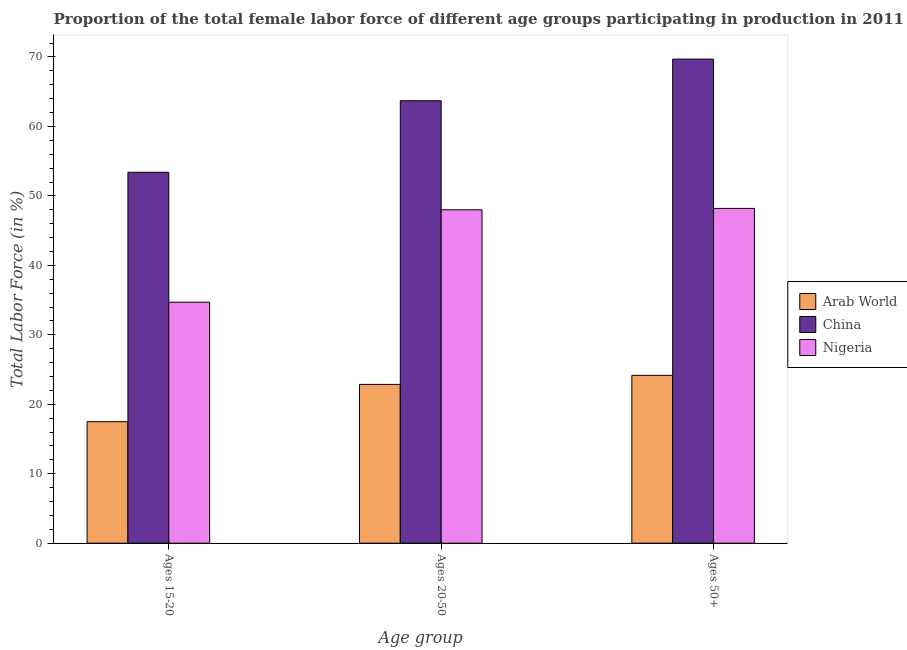How many groups of bars are there?
Offer a terse response. 3. What is the label of the 2nd group of bars from the left?
Keep it short and to the point. Ages 20-50. What is the percentage of female labor force above age 50 in Arab World?
Offer a terse response. 24.17. Across all countries, what is the maximum percentage of female labor force within the age group 15-20?
Ensure brevity in your answer.  53.4. Across all countries, what is the minimum percentage of female labor force within the age group 15-20?
Keep it short and to the point. 17.5. In which country was the percentage of female labor force within the age group 15-20 minimum?
Ensure brevity in your answer.  Arab World. What is the total percentage of female labor force within the age group 15-20 in the graph?
Offer a very short reply. 105.6. What is the difference between the percentage of female labor force within the age group 20-50 in Arab World and that in Nigeria?
Ensure brevity in your answer.  -25.14. What is the difference between the percentage of female labor force within the age group 15-20 in China and the percentage of female labor force above age 50 in Arab World?
Your answer should be very brief. 29.23. What is the average percentage of female labor force within the age group 15-20 per country?
Your response must be concise. 35.2. What is the difference between the percentage of female labor force within the age group 15-20 and percentage of female labor force above age 50 in Arab World?
Your answer should be compact. -6.67. What is the ratio of the percentage of female labor force above age 50 in Nigeria to that in Arab World?
Provide a short and direct response. 1.99. Is the percentage of female labor force above age 50 in Nigeria less than that in Arab World?
Provide a succinct answer. No. What is the difference between the highest and the second highest percentage of female labor force within the age group 20-50?
Offer a terse response. 15.7. What is the difference between the highest and the lowest percentage of female labor force above age 50?
Your answer should be very brief. 45.53. Is the sum of the percentage of female labor force above age 50 in Arab World and China greater than the maximum percentage of female labor force within the age group 15-20 across all countries?
Ensure brevity in your answer.  Yes. What does the 3rd bar from the left in Ages 20-50 represents?
Keep it short and to the point. Nigeria. What does the 1st bar from the right in Ages 20-50 represents?
Your answer should be very brief. Nigeria. Is it the case that in every country, the sum of the percentage of female labor force within the age group 15-20 and percentage of female labor force within the age group 20-50 is greater than the percentage of female labor force above age 50?
Your answer should be very brief. Yes. How many bars are there?
Your answer should be very brief. 9. Are all the bars in the graph horizontal?
Provide a succinct answer. No. How many countries are there in the graph?
Ensure brevity in your answer.  3. What is the difference between two consecutive major ticks on the Y-axis?
Your response must be concise. 10. Does the graph contain any zero values?
Keep it short and to the point. No. Where does the legend appear in the graph?
Make the answer very short. Center right. How are the legend labels stacked?
Give a very brief answer. Vertical. What is the title of the graph?
Give a very brief answer. Proportion of the total female labor force of different age groups participating in production in 2011. What is the label or title of the X-axis?
Your answer should be compact. Age group. What is the label or title of the Y-axis?
Provide a succinct answer. Total Labor Force (in %). What is the Total Labor Force (in %) of Arab World in Ages 15-20?
Give a very brief answer. 17.5. What is the Total Labor Force (in %) of China in Ages 15-20?
Offer a very short reply. 53.4. What is the Total Labor Force (in %) in Nigeria in Ages 15-20?
Offer a terse response. 34.7. What is the Total Labor Force (in %) of Arab World in Ages 20-50?
Give a very brief answer. 22.86. What is the Total Labor Force (in %) in China in Ages 20-50?
Provide a short and direct response. 63.7. What is the Total Labor Force (in %) in Nigeria in Ages 20-50?
Offer a very short reply. 48. What is the Total Labor Force (in %) in Arab World in Ages 50+?
Provide a succinct answer. 24.17. What is the Total Labor Force (in %) in China in Ages 50+?
Your response must be concise. 69.7. What is the Total Labor Force (in %) of Nigeria in Ages 50+?
Provide a succinct answer. 48.2. Across all Age group, what is the maximum Total Labor Force (in %) of Arab World?
Offer a terse response. 24.17. Across all Age group, what is the maximum Total Labor Force (in %) in China?
Offer a terse response. 69.7. Across all Age group, what is the maximum Total Labor Force (in %) in Nigeria?
Provide a short and direct response. 48.2. Across all Age group, what is the minimum Total Labor Force (in %) in Arab World?
Provide a succinct answer. 17.5. Across all Age group, what is the minimum Total Labor Force (in %) of China?
Your answer should be compact. 53.4. Across all Age group, what is the minimum Total Labor Force (in %) of Nigeria?
Your answer should be very brief. 34.7. What is the total Total Labor Force (in %) of Arab World in the graph?
Offer a terse response. 64.53. What is the total Total Labor Force (in %) in China in the graph?
Ensure brevity in your answer.  186.8. What is the total Total Labor Force (in %) of Nigeria in the graph?
Offer a very short reply. 130.9. What is the difference between the Total Labor Force (in %) in Arab World in Ages 15-20 and that in Ages 20-50?
Your answer should be very brief. -5.37. What is the difference between the Total Labor Force (in %) in China in Ages 15-20 and that in Ages 20-50?
Ensure brevity in your answer.  -10.3. What is the difference between the Total Labor Force (in %) of Arab World in Ages 15-20 and that in Ages 50+?
Your response must be concise. -6.67. What is the difference between the Total Labor Force (in %) in China in Ages 15-20 and that in Ages 50+?
Give a very brief answer. -16.3. What is the difference between the Total Labor Force (in %) in Arab World in Ages 20-50 and that in Ages 50+?
Provide a succinct answer. -1.31. What is the difference between the Total Labor Force (in %) of China in Ages 20-50 and that in Ages 50+?
Offer a very short reply. -6. What is the difference between the Total Labor Force (in %) of Nigeria in Ages 20-50 and that in Ages 50+?
Your answer should be compact. -0.2. What is the difference between the Total Labor Force (in %) of Arab World in Ages 15-20 and the Total Labor Force (in %) of China in Ages 20-50?
Provide a short and direct response. -46.2. What is the difference between the Total Labor Force (in %) in Arab World in Ages 15-20 and the Total Labor Force (in %) in Nigeria in Ages 20-50?
Your response must be concise. -30.5. What is the difference between the Total Labor Force (in %) in China in Ages 15-20 and the Total Labor Force (in %) in Nigeria in Ages 20-50?
Provide a short and direct response. 5.4. What is the difference between the Total Labor Force (in %) in Arab World in Ages 15-20 and the Total Labor Force (in %) in China in Ages 50+?
Ensure brevity in your answer.  -52.2. What is the difference between the Total Labor Force (in %) of Arab World in Ages 15-20 and the Total Labor Force (in %) of Nigeria in Ages 50+?
Your answer should be very brief. -30.7. What is the difference between the Total Labor Force (in %) in China in Ages 15-20 and the Total Labor Force (in %) in Nigeria in Ages 50+?
Your answer should be compact. 5.2. What is the difference between the Total Labor Force (in %) of Arab World in Ages 20-50 and the Total Labor Force (in %) of China in Ages 50+?
Ensure brevity in your answer.  -46.84. What is the difference between the Total Labor Force (in %) in Arab World in Ages 20-50 and the Total Labor Force (in %) in Nigeria in Ages 50+?
Keep it short and to the point. -25.34. What is the average Total Labor Force (in %) of Arab World per Age group?
Make the answer very short. 21.51. What is the average Total Labor Force (in %) of China per Age group?
Provide a short and direct response. 62.27. What is the average Total Labor Force (in %) in Nigeria per Age group?
Offer a terse response. 43.63. What is the difference between the Total Labor Force (in %) of Arab World and Total Labor Force (in %) of China in Ages 15-20?
Your response must be concise. -35.9. What is the difference between the Total Labor Force (in %) of Arab World and Total Labor Force (in %) of Nigeria in Ages 15-20?
Provide a succinct answer. -17.2. What is the difference between the Total Labor Force (in %) of Arab World and Total Labor Force (in %) of China in Ages 20-50?
Your answer should be very brief. -40.84. What is the difference between the Total Labor Force (in %) in Arab World and Total Labor Force (in %) in Nigeria in Ages 20-50?
Provide a succinct answer. -25.14. What is the difference between the Total Labor Force (in %) of China and Total Labor Force (in %) of Nigeria in Ages 20-50?
Your response must be concise. 15.7. What is the difference between the Total Labor Force (in %) in Arab World and Total Labor Force (in %) in China in Ages 50+?
Offer a terse response. -45.53. What is the difference between the Total Labor Force (in %) in Arab World and Total Labor Force (in %) in Nigeria in Ages 50+?
Keep it short and to the point. -24.03. What is the difference between the Total Labor Force (in %) in China and Total Labor Force (in %) in Nigeria in Ages 50+?
Your answer should be very brief. 21.5. What is the ratio of the Total Labor Force (in %) in Arab World in Ages 15-20 to that in Ages 20-50?
Make the answer very short. 0.77. What is the ratio of the Total Labor Force (in %) of China in Ages 15-20 to that in Ages 20-50?
Offer a terse response. 0.84. What is the ratio of the Total Labor Force (in %) in Nigeria in Ages 15-20 to that in Ages 20-50?
Your answer should be compact. 0.72. What is the ratio of the Total Labor Force (in %) in Arab World in Ages 15-20 to that in Ages 50+?
Keep it short and to the point. 0.72. What is the ratio of the Total Labor Force (in %) of China in Ages 15-20 to that in Ages 50+?
Your answer should be compact. 0.77. What is the ratio of the Total Labor Force (in %) of Nigeria in Ages 15-20 to that in Ages 50+?
Provide a short and direct response. 0.72. What is the ratio of the Total Labor Force (in %) in Arab World in Ages 20-50 to that in Ages 50+?
Offer a very short reply. 0.95. What is the ratio of the Total Labor Force (in %) of China in Ages 20-50 to that in Ages 50+?
Offer a very short reply. 0.91. What is the ratio of the Total Labor Force (in %) in Nigeria in Ages 20-50 to that in Ages 50+?
Give a very brief answer. 1. What is the difference between the highest and the second highest Total Labor Force (in %) of Arab World?
Make the answer very short. 1.31. What is the difference between the highest and the second highest Total Labor Force (in %) of China?
Your response must be concise. 6. What is the difference between the highest and the lowest Total Labor Force (in %) of Arab World?
Your answer should be very brief. 6.67. 